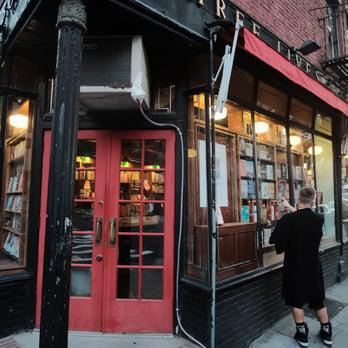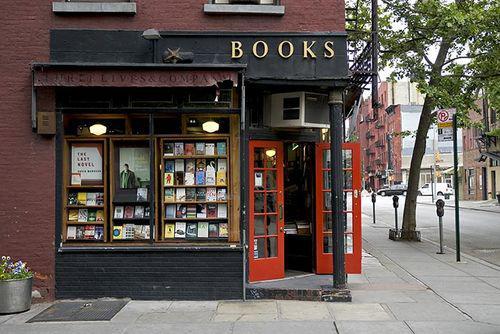The first image is the image on the left, the second image is the image on the right. Examine the images to the left and right. Is the description "One of the images shows humans inside the shop." accurate? Answer yes or no. No. The first image is the image on the left, the second image is the image on the right. Considering the images on both sides, is "Red rectangular signs with white lettering are displayed above ground-level in one scene." valid? Answer yes or no. No. 